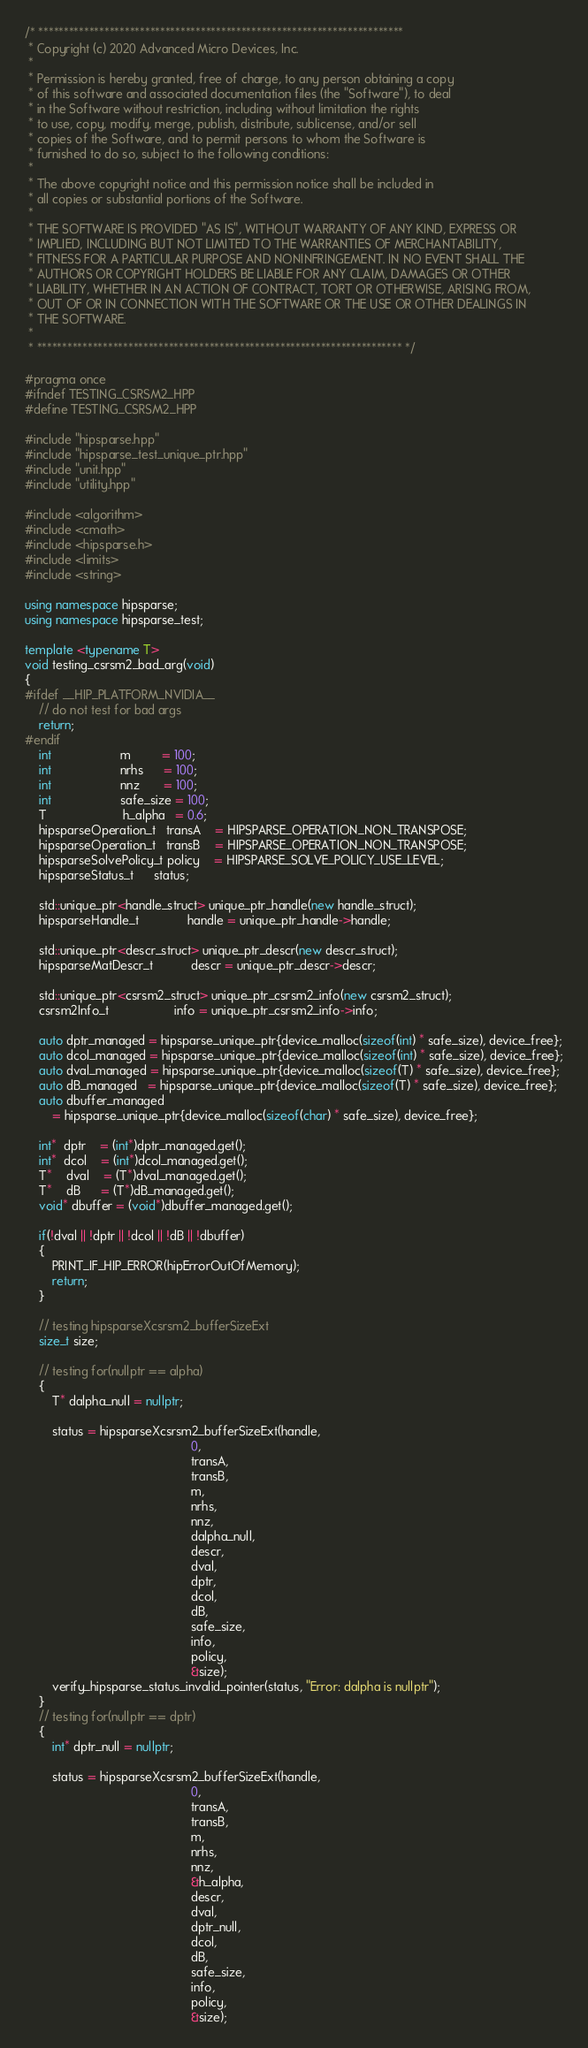<code> <loc_0><loc_0><loc_500><loc_500><_C++_>/* ************************************************************************
 * Copyright (c) 2020 Advanced Micro Devices, Inc.
 *
 * Permission is hereby granted, free of charge, to any person obtaining a copy
 * of this software and associated documentation files (the "Software"), to deal
 * in the Software without restriction, including without limitation the rights
 * to use, copy, modify, merge, publish, distribute, sublicense, and/or sell
 * copies of the Software, and to permit persons to whom the Software is
 * furnished to do so, subject to the following conditions:
 *
 * The above copyright notice and this permission notice shall be included in
 * all copies or substantial portions of the Software.
 *
 * THE SOFTWARE IS PROVIDED "AS IS", WITHOUT WARRANTY OF ANY KIND, EXPRESS OR
 * IMPLIED, INCLUDING BUT NOT LIMITED TO THE WARRANTIES OF MERCHANTABILITY,
 * FITNESS FOR A PARTICULAR PURPOSE AND NONINFRINGEMENT. IN NO EVENT SHALL THE
 * AUTHORS OR COPYRIGHT HOLDERS BE LIABLE FOR ANY CLAIM, DAMAGES OR OTHER
 * LIABILITY, WHETHER IN AN ACTION OF CONTRACT, TORT OR OTHERWISE, ARISING FROM,
 * OUT OF OR IN CONNECTION WITH THE SOFTWARE OR THE USE OR OTHER DEALINGS IN
 * THE SOFTWARE.
 *
 * ************************************************************************ */

#pragma once
#ifndef TESTING_CSRSM2_HPP
#define TESTING_CSRSM2_HPP

#include "hipsparse.hpp"
#include "hipsparse_test_unique_ptr.hpp"
#include "unit.hpp"
#include "utility.hpp"

#include <algorithm>
#include <cmath>
#include <hipsparse.h>
#include <limits>
#include <string>

using namespace hipsparse;
using namespace hipsparse_test;

template <typename T>
void testing_csrsm2_bad_arg(void)
{
#ifdef __HIP_PLATFORM_NVIDIA__
    // do not test for bad args
    return;
#endif
    int                    m         = 100;
    int                    nrhs      = 100;
    int                    nnz       = 100;
    int                    safe_size = 100;
    T                      h_alpha   = 0.6;
    hipsparseOperation_t   transA    = HIPSPARSE_OPERATION_NON_TRANSPOSE;
    hipsparseOperation_t   transB    = HIPSPARSE_OPERATION_NON_TRANSPOSE;
    hipsparseSolvePolicy_t policy    = HIPSPARSE_SOLVE_POLICY_USE_LEVEL;
    hipsparseStatus_t      status;

    std::unique_ptr<handle_struct> unique_ptr_handle(new handle_struct);
    hipsparseHandle_t              handle = unique_ptr_handle->handle;

    std::unique_ptr<descr_struct> unique_ptr_descr(new descr_struct);
    hipsparseMatDescr_t           descr = unique_ptr_descr->descr;

    std::unique_ptr<csrsm2_struct> unique_ptr_csrsm2_info(new csrsm2_struct);
    csrsm2Info_t                   info = unique_ptr_csrsm2_info->info;

    auto dptr_managed = hipsparse_unique_ptr{device_malloc(sizeof(int) * safe_size), device_free};
    auto dcol_managed = hipsparse_unique_ptr{device_malloc(sizeof(int) * safe_size), device_free};
    auto dval_managed = hipsparse_unique_ptr{device_malloc(sizeof(T) * safe_size), device_free};
    auto dB_managed   = hipsparse_unique_ptr{device_malloc(sizeof(T) * safe_size), device_free};
    auto dbuffer_managed
        = hipsparse_unique_ptr{device_malloc(sizeof(char) * safe_size), device_free};

    int*  dptr    = (int*)dptr_managed.get();
    int*  dcol    = (int*)dcol_managed.get();
    T*    dval    = (T*)dval_managed.get();
    T*    dB      = (T*)dB_managed.get();
    void* dbuffer = (void*)dbuffer_managed.get();

    if(!dval || !dptr || !dcol || !dB || !dbuffer)
    {
        PRINT_IF_HIP_ERROR(hipErrorOutOfMemory);
        return;
    }

    // testing hipsparseXcsrsm2_bufferSizeExt
    size_t size;

    // testing for(nullptr == alpha)
    {
        T* dalpha_null = nullptr;

        status = hipsparseXcsrsm2_bufferSizeExt(handle,
                                                0,
                                                transA,
                                                transB,
                                                m,
                                                nrhs,
                                                nnz,
                                                dalpha_null,
                                                descr,
                                                dval,
                                                dptr,
                                                dcol,
                                                dB,
                                                safe_size,
                                                info,
                                                policy,
                                                &size);
        verify_hipsparse_status_invalid_pointer(status, "Error: dalpha is nullptr");
    }
    // testing for(nullptr == dptr)
    {
        int* dptr_null = nullptr;

        status = hipsparseXcsrsm2_bufferSizeExt(handle,
                                                0,
                                                transA,
                                                transB,
                                                m,
                                                nrhs,
                                                nnz,
                                                &h_alpha,
                                                descr,
                                                dval,
                                                dptr_null,
                                                dcol,
                                                dB,
                                                safe_size,
                                                info,
                                                policy,
                                                &size);</code> 